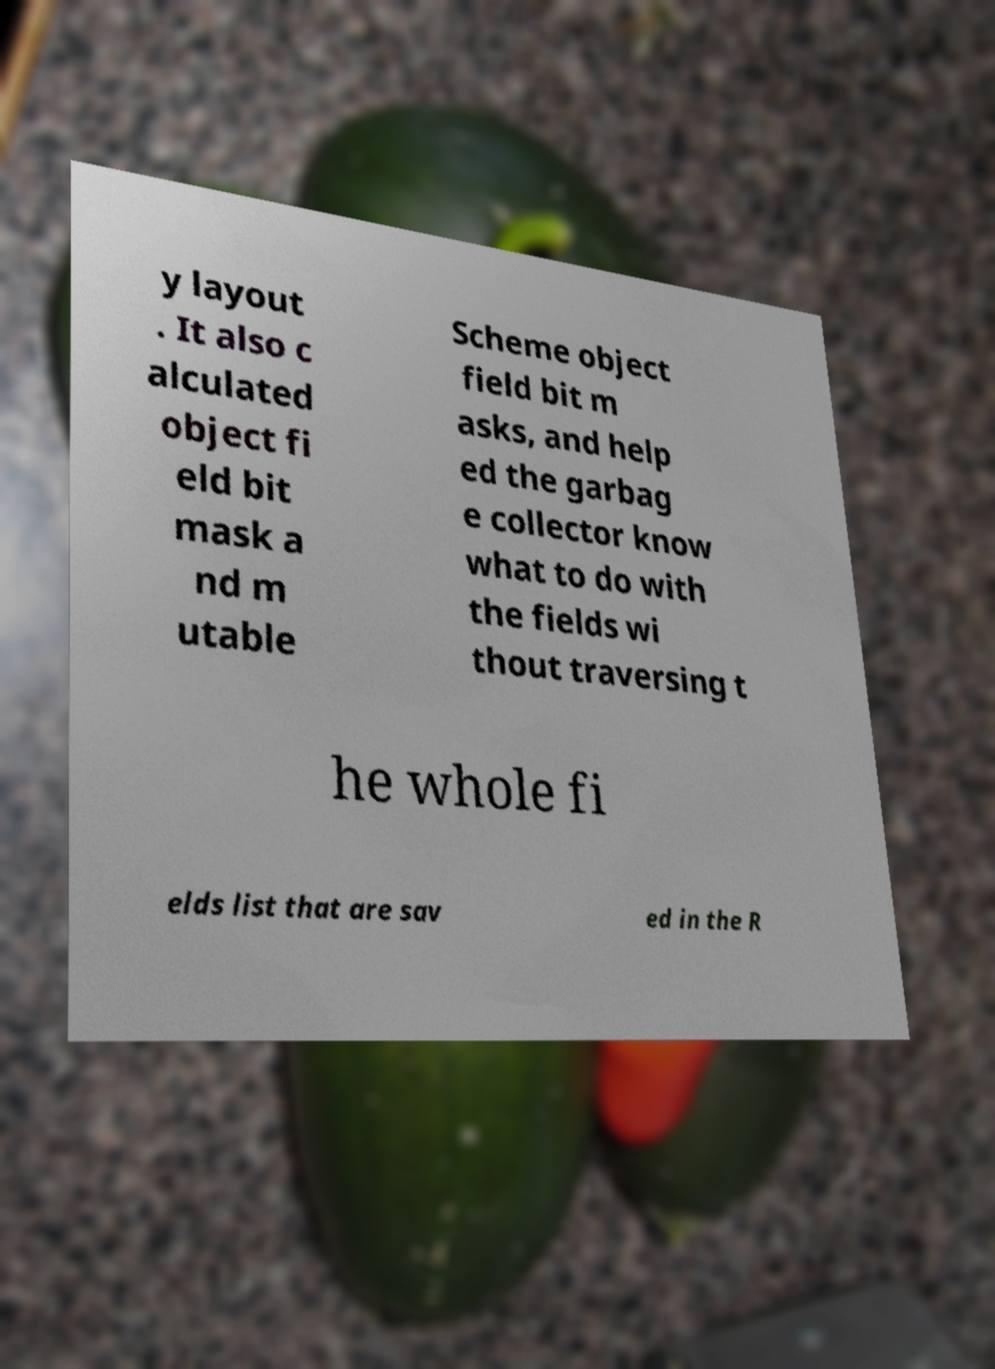Could you extract and type out the text from this image? y layout . It also c alculated object fi eld bit mask a nd m utable Scheme object field bit m asks, and help ed the garbag e collector know what to do with the fields wi thout traversing t he whole fi elds list that are sav ed in the R 